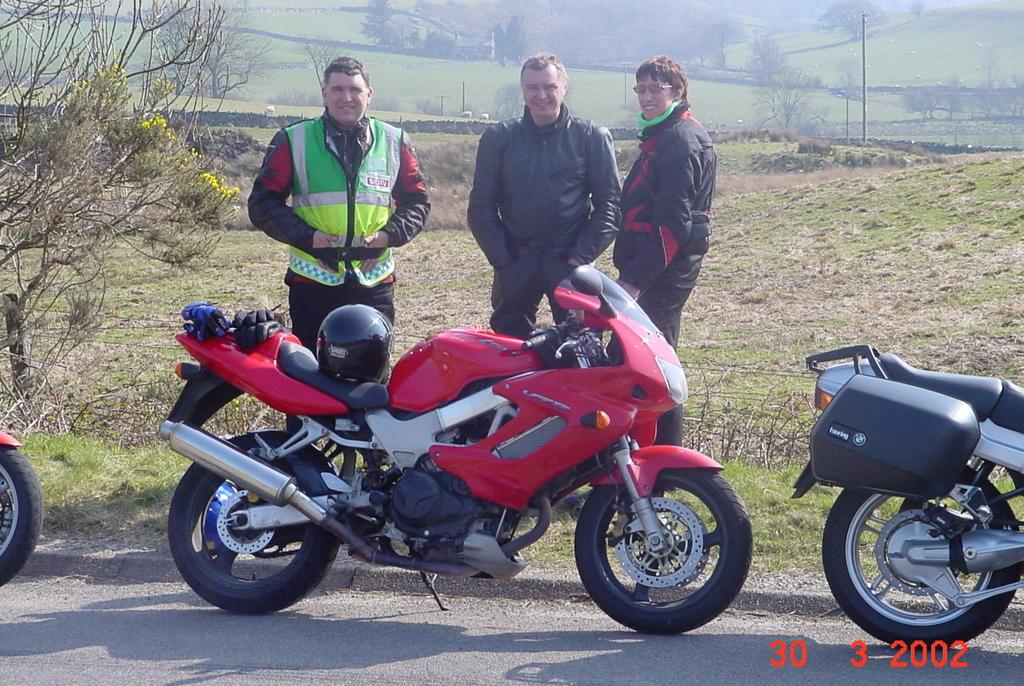What is happening on the road in the image? There are people on the road in the image. What can be seen in the background of the image? There are trees and electric poles in the background of the image. Are there any numbers visible in the image? Yes, there are some numbers visible in the bottom right corner of the image. What type of curtain can be seen in the image? There is no curtain present in the image. How hot is the temperature in the image? The image does not provide information about the temperature, so it cannot be determined. 